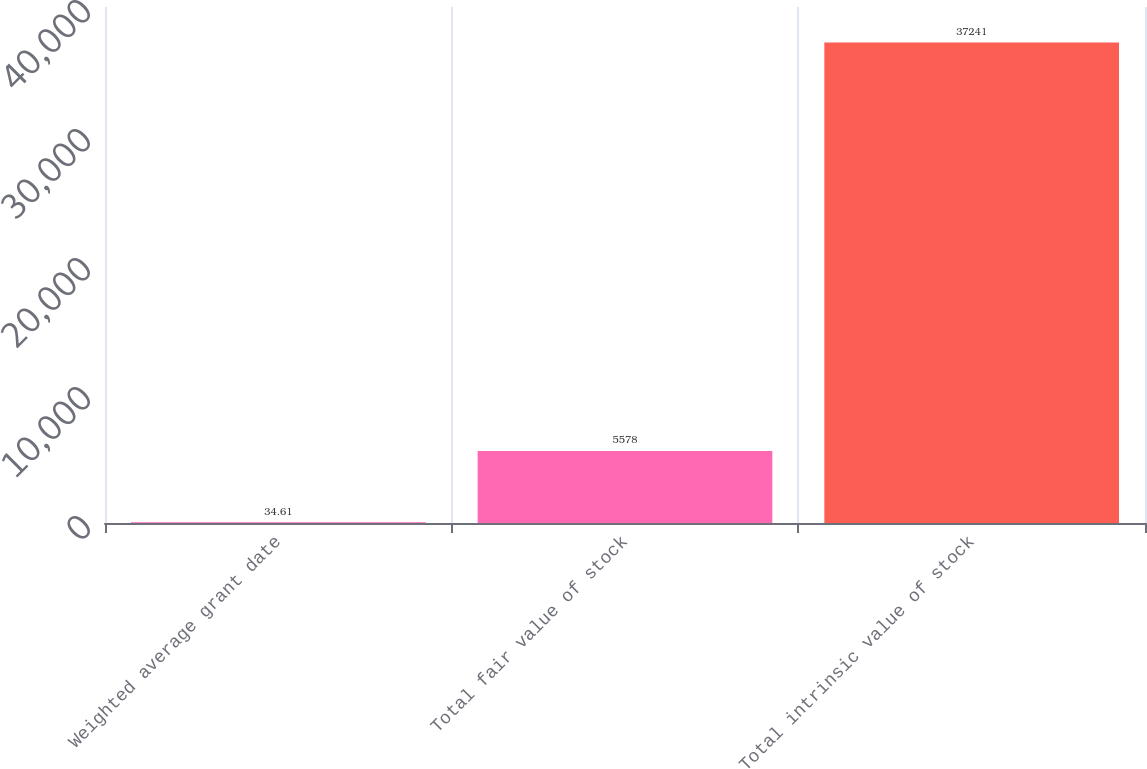Convert chart to OTSL. <chart><loc_0><loc_0><loc_500><loc_500><bar_chart><fcel>Weighted average grant date<fcel>Total fair value of stock<fcel>Total intrinsic value of stock<nl><fcel>34.61<fcel>5578<fcel>37241<nl></chart> 